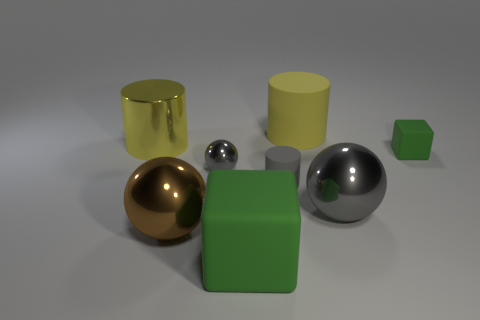What is the shape of the tiny gray object that is the same material as the brown sphere?
Give a very brief answer. Sphere. Is the number of small gray spheres behind the small gray ball less than the number of big objects that are in front of the yellow metal cylinder?
Make the answer very short. Yes. Are there more gray rubber cylinders than shiny objects?
Your answer should be compact. No. What is the material of the small block?
Your answer should be compact. Rubber. There is a rubber cylinder that is behind the yellow shiny thing; what color is it?
Provide a short and direct response. Yellow. Are there more metal spheres to the left of the tiny metal object than yellow objects to the left of the small green thing?
Ensure brevity in your answer.  No. There is a gray shiny ball in front of the matte cylinder that is in front of the tiny matte thing that is behind the tiny gray shiny thing; how big is it?
Give a very brief answer. Large. Is there a rubber cylinder of the same color as the tiny metal ball?
Make the answer very short. Yes. How many yellow metallic cylinders are there?
Make the answer very short. 1. What is the material of the block that is right of the small gray thing right of the rubber cube that is left of the tiny block?
Ensure brevity in your answer.  Rubber. 